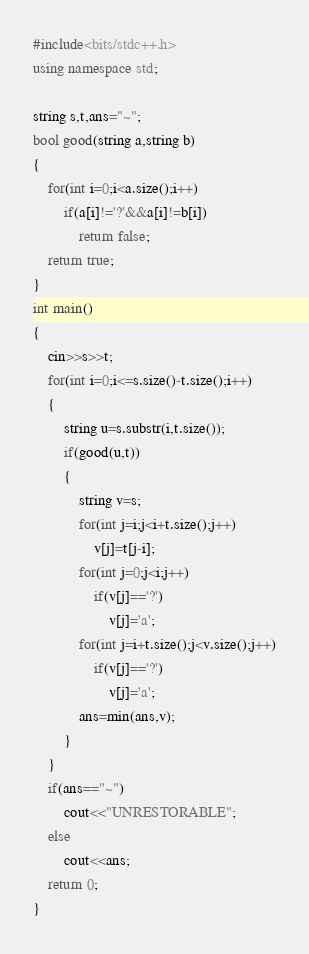<code> <loc_0><loc_0><loc_500><loc_500><_C++_>#include<bits/stdc++.h>
using namespace std;

string s,t,ans="~";
bool good(string a,string b)
{
	for(int i=0;i<a.size();i++)
		if(a[i]!='?'&&a[i]!=b[i])
			return false;
	return true;
}
int main()
{
	cin>>s>>t;
	for(int i=0;i<=s.size()-t.size();i++)
	{
		string u=s.substr(i,t.size());
		if(good(u,t))
		{
			string v=s;
			for(int j=i;j<i+t.size();j++)
				v[j]=t[j-i];
			for(int j=0;j<i;j++)
				if(v[j]=='?')
					v[j]='a';
			for(int j=i+t.size();j<v.size();j++)
				if(v[j]=='?')
					v[j]='a';
			ans=min(ans,v);
		}
	}
	if(ans=="~")
		cout<<"UNRESTORABLE";
	else
		cout<<ans;
	return 0;
}</code> 